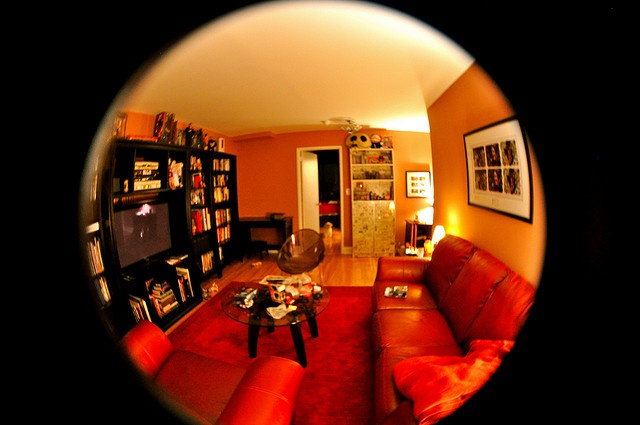Describe the objects in this image and their specific colors. I can see book in black, maroon, brown, and orange tones, couch in black, maroon, and red tones, chair in black, maroon, and red tones, couch in black, maroon, and red tones, and tv in black, maroon, pink, and brown tones in this image. 